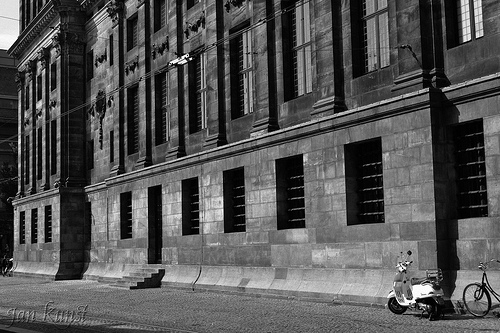What details can you describe about the wall of the building? The wall of the building is constructed with dark stone bricks arranged in a uniform pattern. There are several evenly spaced windows with bars on them. The wall has a solemn and historic appearance, adding to the grandeur of the building. 